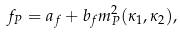<formula> <loc_0><loc_0><loc_500><loc_500>f _ { P } = a _ { f } + b _ { f } m _ { P } ^ { 2 } ( \kappa _ { 1 } , \kappa _ { 2 } ) ,</formula> 